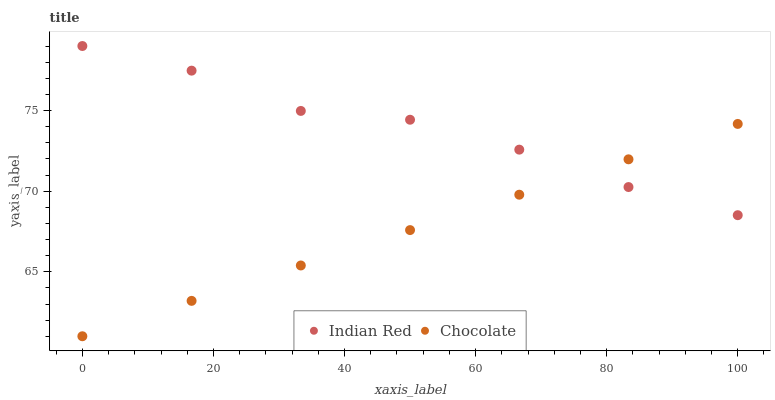Does Chocolate have the minimum area under the curve?
Answer yes or no. Yes. Does Indian Red have the maximum area under the curve?
Answer yes or no. Yes. Does Chocolate have the maximum area under the curve?
Answer yes or no. No. Is Chocolate the smoothest?
Answer yes or no. Yes. Is Indian Red the roughest?
Answer yes or no. Yes. Is Chocolate the roughest?
Answer yes or no. No. Does Chocolate have the lowest value?
Answer yes or no. Yes. Does Indian Red have the highest value?
Answer yes or no. Yes. Does Chocolate have the highest value?
Answer yes or no. No. Does Chocolate intersect Indian Red?
Answer yes or no. Yes. Is Chocolate less than Indian Red?
Answer yes or no. No. Is Chocolate greater than Indian Red?
Answer yes or no. No. 